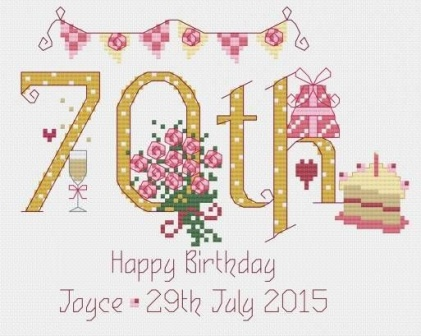What do you see happening in this image? The image captures the delightful ambiance of a 70th birthday celebration for someone named Joyce on the 29th of July, 2015. A decorative banner with the celebration year prominently announces the milestone in hues of pink and white, flirted on both sides by joyous design elements suggestive of festivity, including a bouquet of intricate pink roses aligned with elegance. An enticing slice of birthday cake to the left hints at the festivities involved, all against a contrasting white background, which not only brings out the vibrancy of the decorations but also echoes the joyous essence of such a significant life event. 